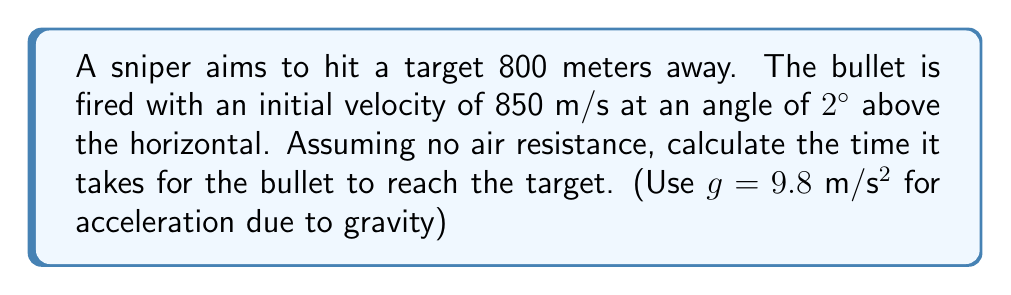Can you answer this question? To solve this problem, we'll use the equations of motion for projectile motion:

1) Horizontal motion: $x = v_0 \cos(\theta) \cdot t$
2) Vertical motion: $y = v_0 \sin(\theta) \cdot t - \frac{1}{2}gt^2$

Where:
$x$ is the horizontal distance (800 m)
$v_0$ is the initial velocity (850 m/s)
$\theta$ is the angle of elevation (2°)
$t$ is the time (what we're solving for)
$g$ is the acceleration due to gravity (9.8 m/s²)

Step 1: Use the horizontal motion equation to find t:

$800 = 850 \cos(2°) \cdot t$

$t = \frac{800}{850 \cos(2°)} \approx 0.9415$ seconds

Step 2: Verify using the vertical motion equation:

$y = 850 \sin(2°) \cdot 0.9415 - \frac{1}{2}(9.8)(0.9415)^2$

$y \approx 27.9 - 4.3 = 23.6$ meters

This positive y value confirms that the bullet is still above the horizontal at 800 meters, which is consistent with the upward angle of fire.
Answer: $t \approx 0.9415$ seconds 